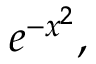<formula> <loc_0><loc_0><loc_500><loc_500>e ^ { - x ^ { 2 } } ,</formula> 